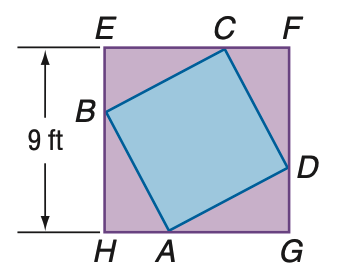Answer the mathemtical geometry problem and directly provide the correct option letter.
Question: In the figure, the vertices of quadrilateral A B C D intersect square E F G H and divide its sides into segments with measure that have a ratio of 1:2. Find the area of A B C D.
Choices: A: 40.5 B: 45 C: 63 D: 81 B 